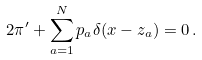Convert formula to latex. <formula><loc_0><loc_0><loc_500><loc_500>2 \pi ^ { \prime } + \sum _ { a = 1 } ^ { N } p _ { a } \delta ( x - z _ { a } ) = 0 \, .</formula> 